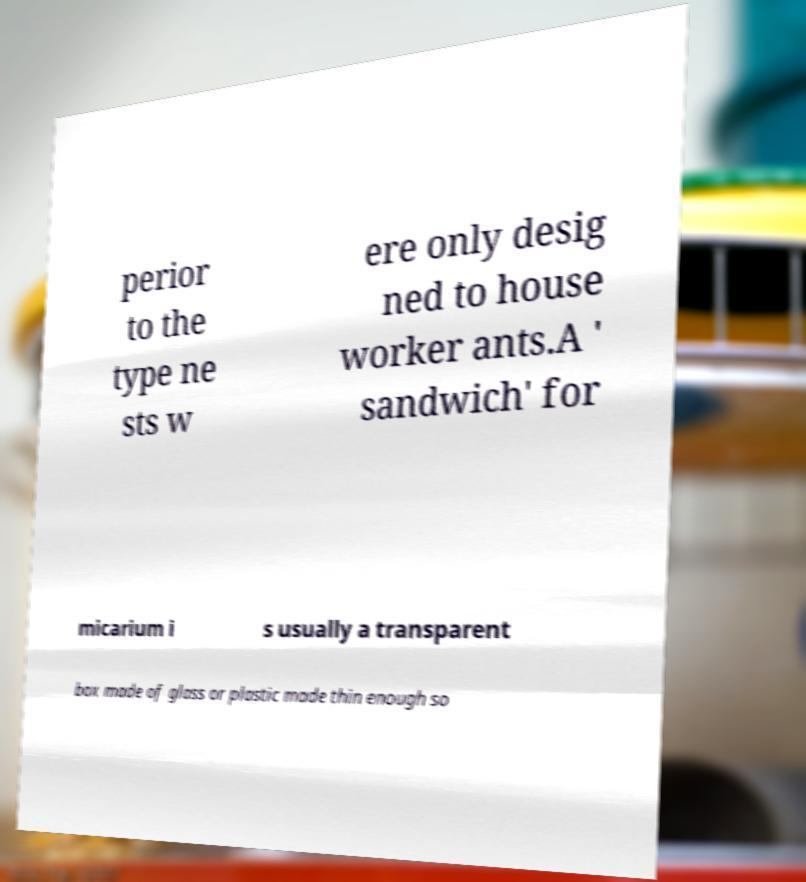I need the written content from this picture converted into text. Can you do that? perior to the type ne sts w ere only desig ned to house worker ants.A ' sandwich' for micarium i s usually a transparent box made of glass or plastic made thin enough so 